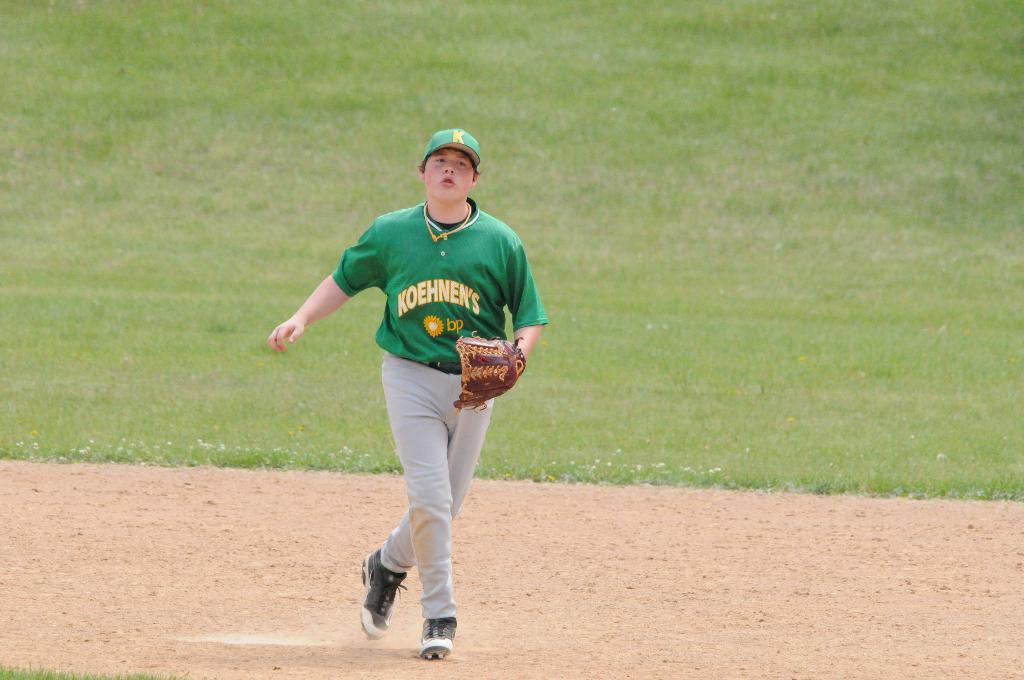What team name is this player associated with?
Your answer should be compact. Koehnek's. What sponsor is on the shirt?
Your response must be concise. Bp. 